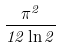<formula> <loc_0><loc_0><loc_500><loc_500>\frac { \pi ^ { 2 } } { 1 2 \ln 2 }</formula> 